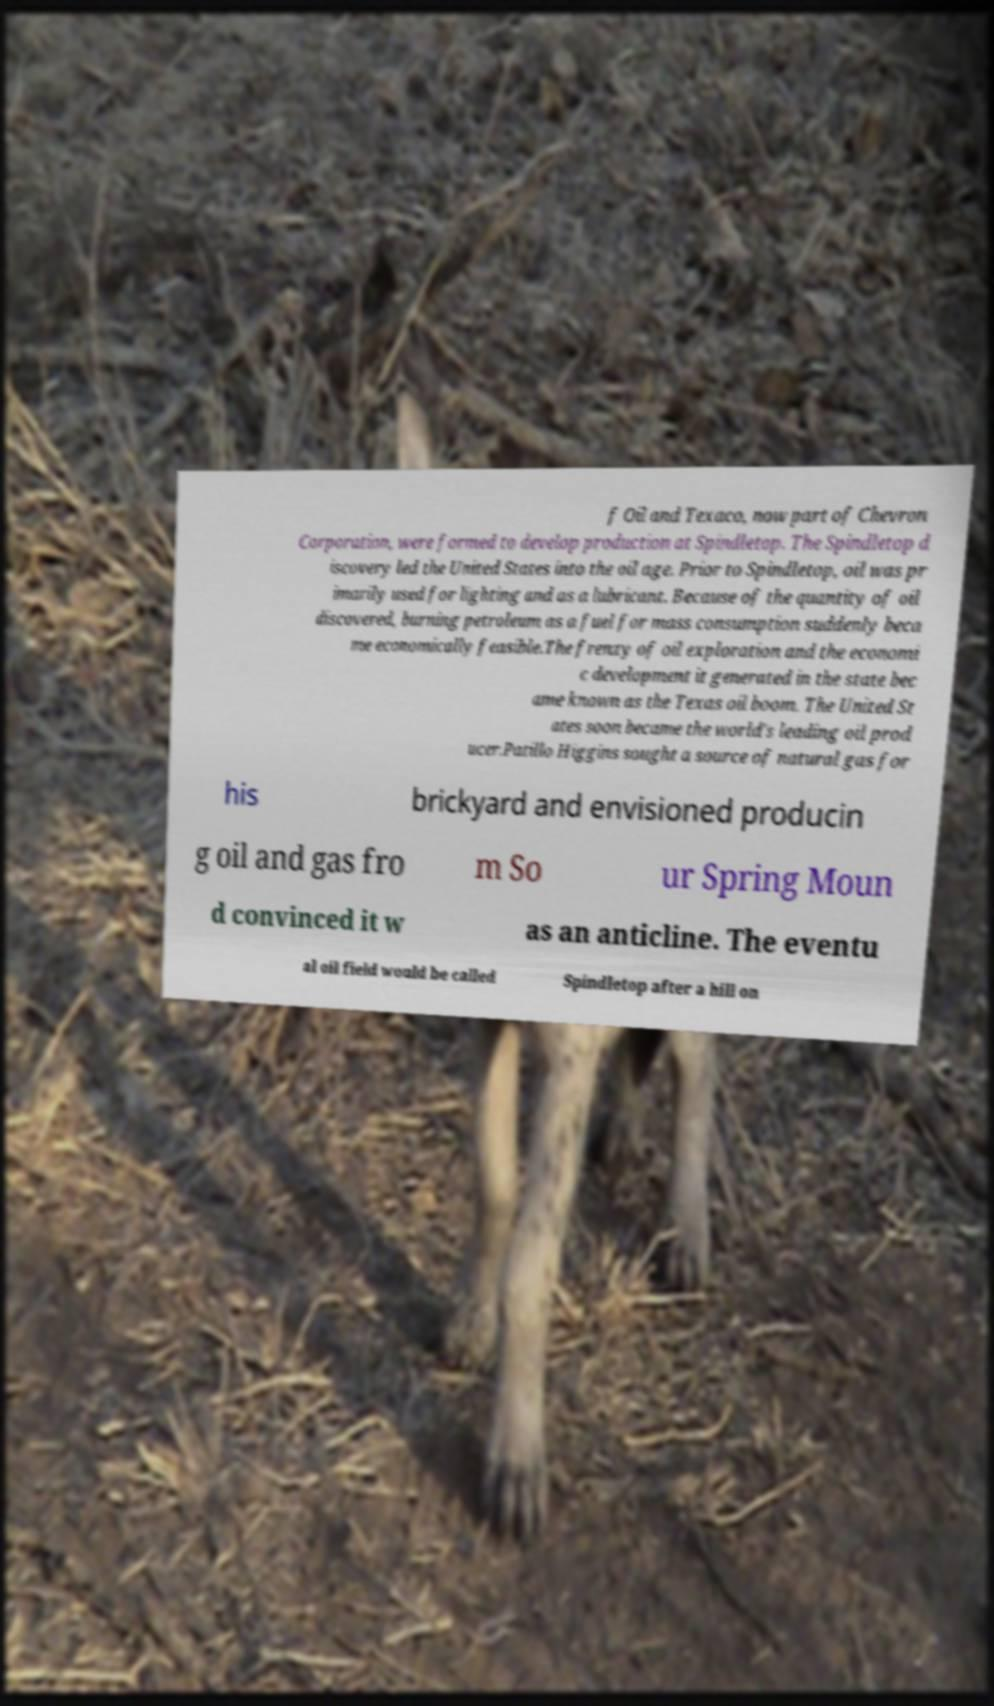Can you read and provide the text displayed in the image?This photo seems to have some interesting text. Can you extract and type it out for me? f Oil and Texaco, now part of Chevron Corporation, were formed to develop production at Spindletop. The Spindletop d iscovery led the United States into the oil age. Prior to Spindletop, oil was pr imarily used for lighting and as a lubricant. Because of the quantity of oil discovered, burning petroleum as a fuel for mass consumption suddenly beca me economically feasible.The frenzy of oil exploration and the economi c development it generated in the state bec ame known as the Texas oil boom. The United St ates soon became the world's leading oil prod ucer.Patillo Higgins sought a source of natural gas for his brickyard and envisioned producin g oil and gas fro m So ur Spring Moun d convinced it w as an anticline. The eventu al oil field would be called Spindletop after a hill on 